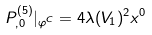Convert formula to latex. <formula><loc_0><loc_0><loc_500><loc_500>P ^ { ( 5 ) } _ { , 0 } | _ { \varphi ^ { C } } = 4 \lambda ( V _ { 1 } ) ^ { 2 } x ^ { 0 }</formula> 